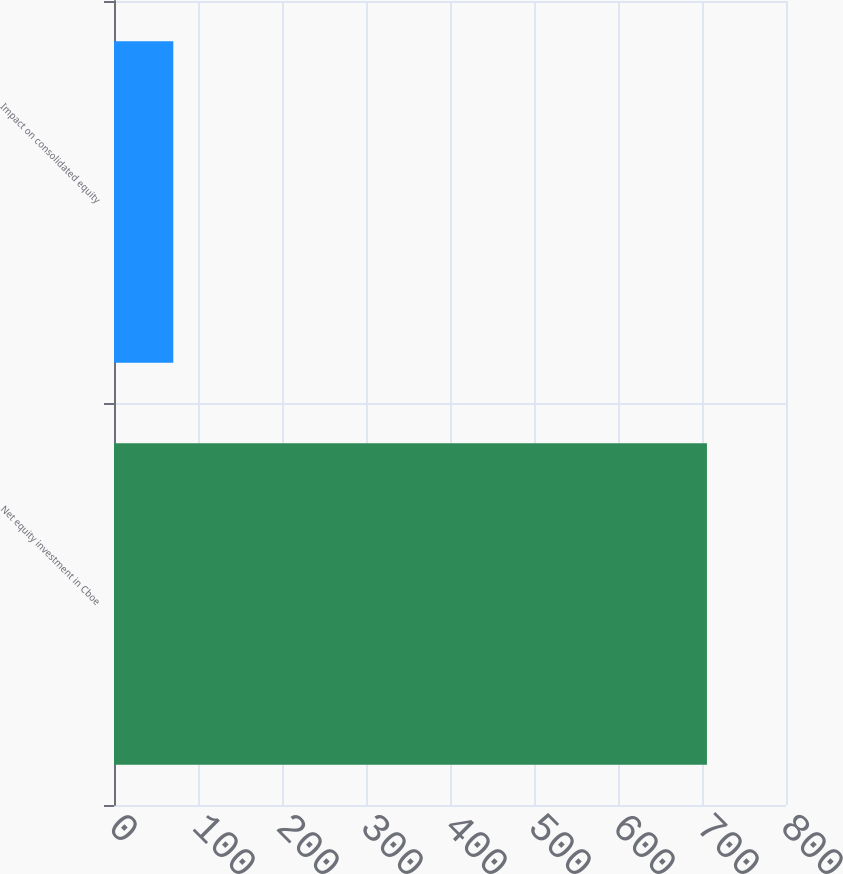Convert chart. <chart><loc_0><loc_0><loc_500><loc_500><bar_chart><fcel>Net equity investment in Cboe<fcel>Impact on consolidated equity<nl><fcel>705.9<fcel>70.6<nl></chart> 